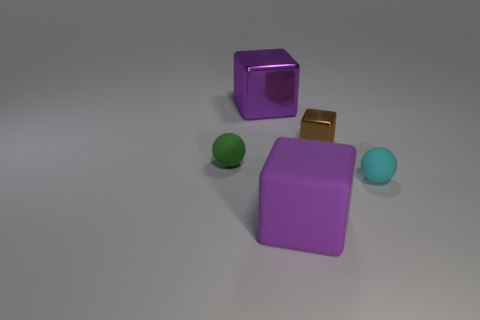There is a thing that is the same color as the large metallic cube; what material is it?
Give a very brief answer. Rubber. Is there another big object that has the same color as the large rubber object?
Your answer should be compact. Yes. There is a small ball that is to the right of the tiny shiny object; what number of cyan matte objects are in front of it?
Your answer should be very brief. 0. Is the large rubber thing the same color as the big metallic thing?
Offer a terse response. Yes. What number of other things are made of the same material as the brown thing?
Your response must be concise. 1. There is a rubber object on the right side of the large matte object that is in front of the purple metal block; what is its shape?
Make the answer very short. Sphere. What size is the purple cube on the right side of the big purple metallic cube?
Give a very brief answer. Large. Is the cyan ball made of the same material as the green thing?
Offer a very short reply. Yes. There is a big object that is the same material as the small cyan sphere; what is its shape?
Your answer should be very brief. Cube. Is there any other thing that is the same color as the small metallic cube?
Provide a succinct answer. No. 